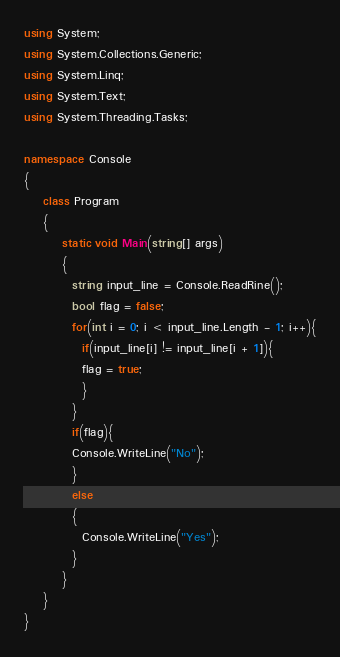Convert code to text. <code><loc_0><loc_0><loc_500><loc_500><_C#_>using System;
using System.Collections.Generic;
using System.Linq;
using System.Text;
using System.Threading.Tasks;

namespace Console
{
    class Program
    {
        static void Main(string[] args)
        {
          string input_line = Console.ReadRine();
          bool flag = false;
          for(int i = 0; i < input_line.Length - 1; i++){
			if(input_line[i] != input_line[i + 1]){
            flag = true;
            }
          }
          if(flag){
          Console.WriteLine("No");
          }
          else
          {
            Console.WriteLine("Yes");
          }
        }
    }
}
</code> 